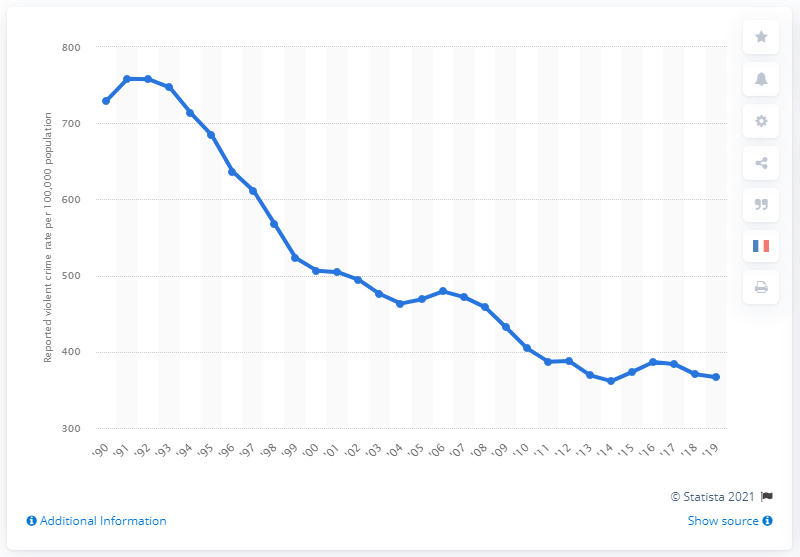List a handful of essential elements in this visual. In 2019, the nationwide violent crime rate was 366.7 per 100,000 people. 